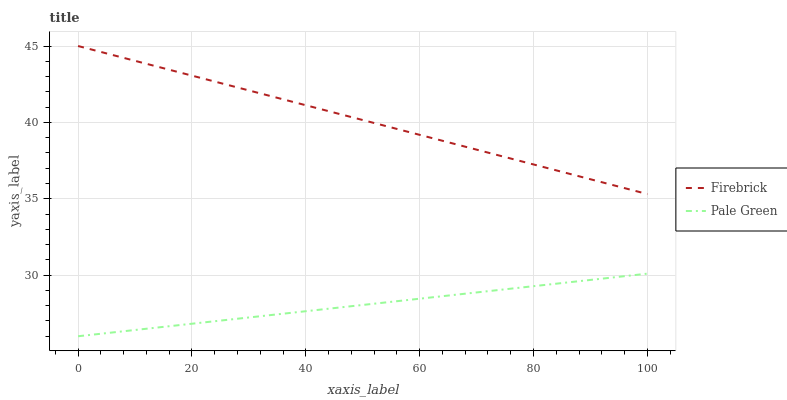Does Pale Green have the minimum area under the curve?
Answer yes or no. Yes. Does Firebrick have the maximum area under the curve?
Answer yes or no. Yes. Does Pale Green have the maximum area under the curve?
Answer yes or no. No. Is Firebrick the smoothest?
Answer yes or no. Yes. Is Pale Green the roughest?
Answer yes or no. Yes. Does Pale Green have the lowest value?
Answer yes or no. Yes. Does Firebrick have the highest value?
Answer yes or no. Yes. Does Pale Green have the highest value?
Answer yes or no. No. Is Pale Green less than Firebrick?
Answer yes or no. Yes. Is Firebrick greater than Pale Green?
Answer yes or no. Yes. Does Pale Green intersect Firebrick?
Answer yes or no. No. 